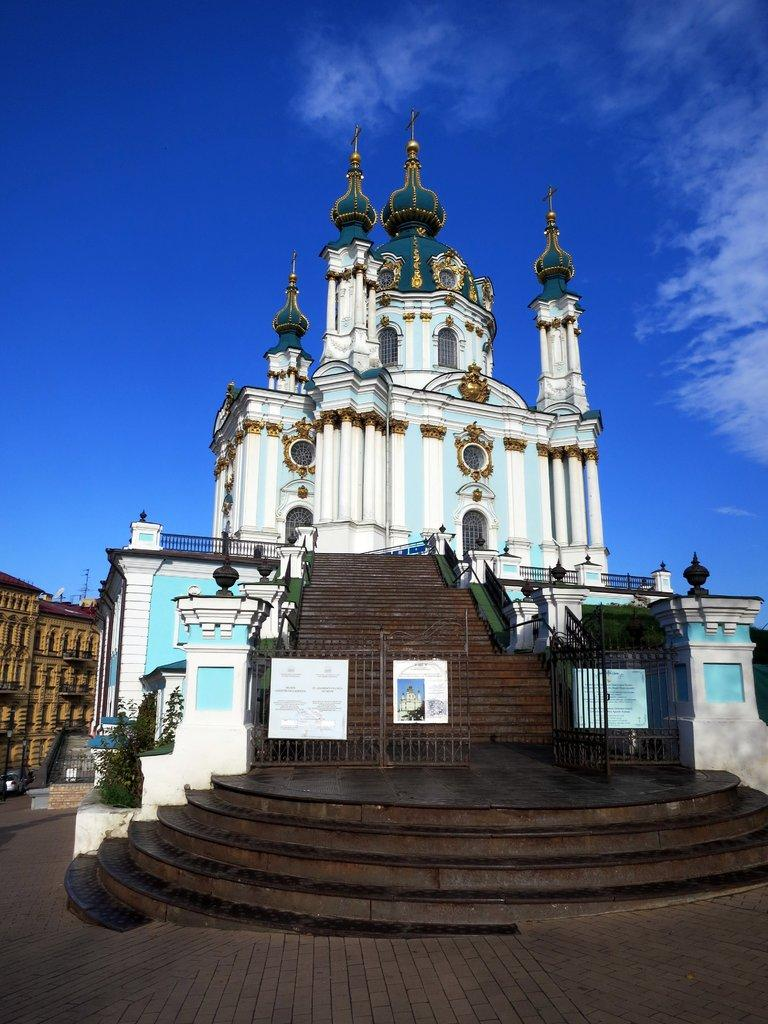What type of structures can be seen in the image? There are buildings in the image. Are there any architectural features visible in the image? Yes, there are stairs in the image. What is the condition of the sky in the image? The sky is clear in the image. What type of vegetation is present in the image? There are plants in the image. How many ladybugs are crawling on the buildings in the image? There are no ladybugs present in the image; it features buildings, stairs, a clear sky, and plants. What type of territory is depicted in the image? The image does not depict a specific territory; it simply shows buildings, stairs, a clear sky, and plants. 